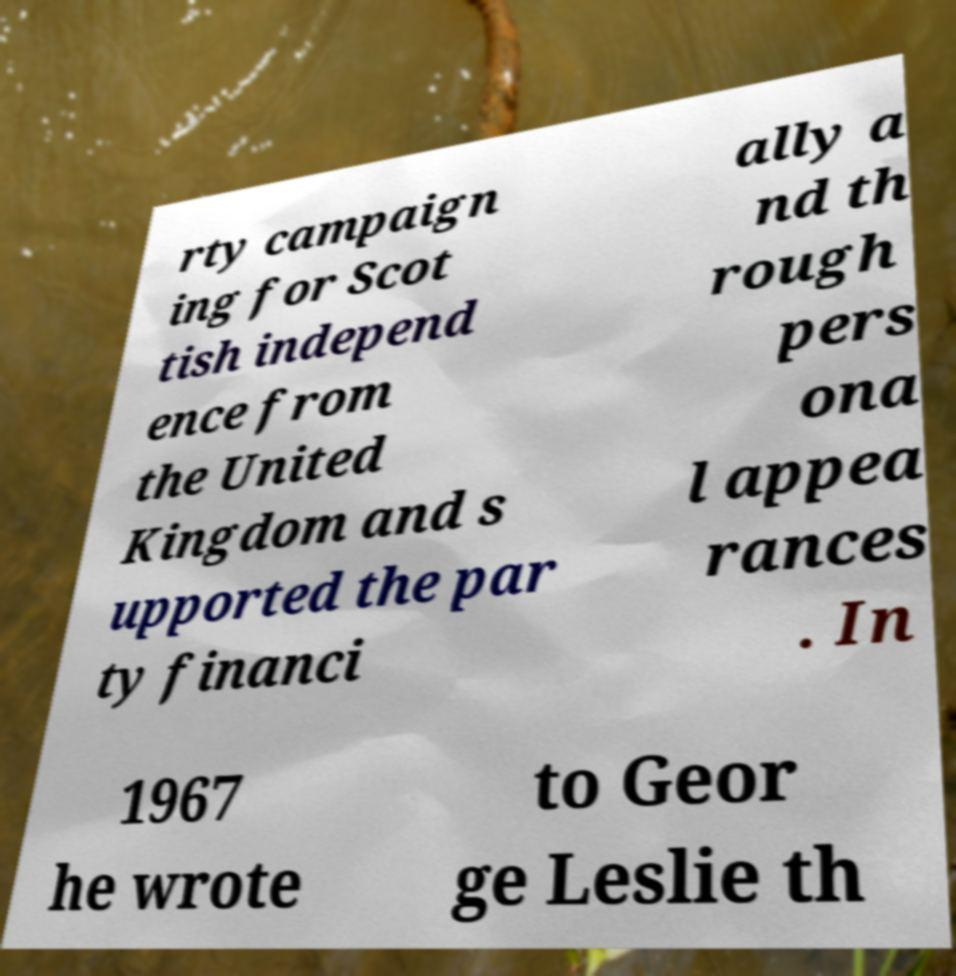There's text embedded in this image that I need extracted. Can you transcribe it verbatim? rty campaign ing for Scot tish independ ence from the United Kingdom and s upported the par ty financi ally a nd th rough pers ona l appea rances . In 1967 he wrote to Geor ge Leslie th 